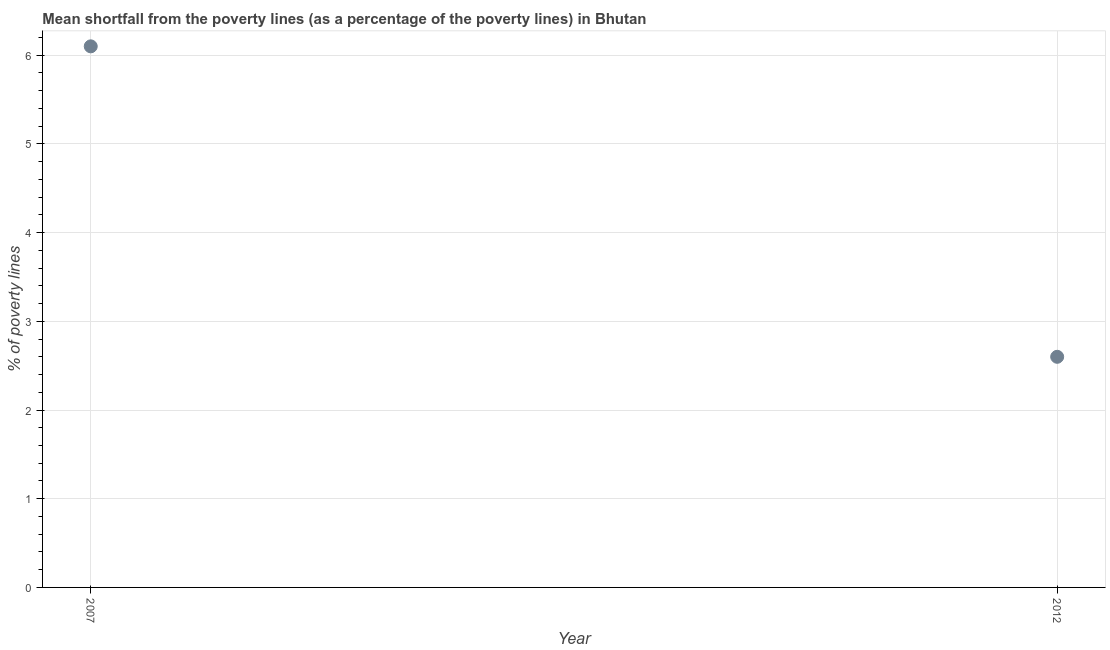What is the poverty gap at national poverty lines in 2007?
Offer a very short reply. 6.1. Across all years, what is the maximum poverty gap at national poverty lines?
Keep it short and to the point. 6.1. In which year was the poverty gap at national poverty lines maximum?
Provide a short and direct response. 2007. In which year was the poverty gap at national poverty lines minimum?
Your response must be concise. 2012. What is the difference between the poverty gap at national poverty lines in 2007 and 2012?
Your response must be concise. 3.5. What is the average poverty gap at national poverty lines per year?
Make the answer very short. 4.35. What is the median poverty gap at national poverty lines?
Your answer should be very brief. 4.35. In how many years, is the poverty gap at national poverty lines greater than 5.2 %?
Offer a very short reply. 1. What is the ratio of the poverty gap at national poverty lines in 2007 to that in 2012?
Give a very brief answer. 2.35. Is the poverty gap at national poverty lines in 2007 less than that in 2012?
Give a very brief answer. No. In how many years, is the poverty gap at national poverty lines greater than the average poverty gap at national poverty lines taken over all years?
Give a very brief answer. 1. Does the poverty gap at national poverty lines monotonically increase over the years?
Keep it short and to the point. No. What is the difference between two consecutive major ticks on the Y-axis?
Your answer should be very brief. 1. Are the values on the major ticks of Y-axis written in scientific E-notation?
Make the answer very short. No. What is the title of the graph?
Your answer should be very brief. Mean shortfall from the poverty lines (as a percentage of the poverty lines) in Bhutan. What is the label or title of the Y-axis?
Make the answer very short. % of poverty lines. What is the % of poverty lines in 2007?
Keep it short and to the point. 6.1. What is the % of poverty lines in 2012?
Offer a very short reply. 2.6. What is the difference between the % of poverty lines in 2007 and 2012?
Ensure brevity in your answer.  3.5. What is the ratio of the % of poverty lines in 2007 to that in 2012?
Give a very brief answer. 2.35. 